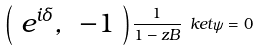<formula> <loc_0><loc_0><loc_500><loc_500>\left ( \begin{array} { c c } e ^ { i \delta } , & - 1 \end{array} \right ) \frac { 1 } { 1 - z B } \ k e t { \psi } = 0</formula> 